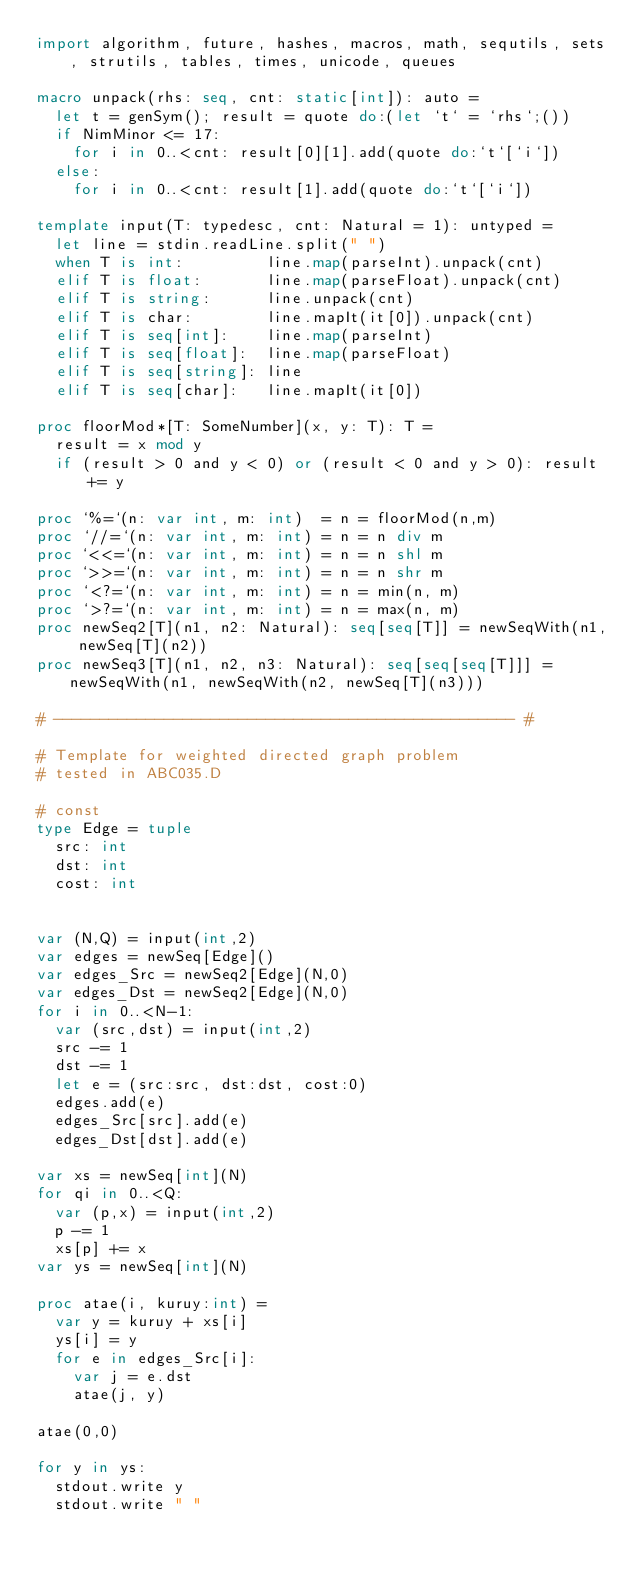Convert code to text. <code><loc_0><loc_0><loc_500><loc_500><_Nim_>import algorithm, future, hashes, macros, math, sequtils, sets, strutils, tables, times, unicode, queues
 
macro unpack(rhs: seq, cnt: static[int]): auto =
  let t = genSym(); result = quote do:(let `t` = `rhs`;())
  if NimMinor <= 17:
    for i in 0..<cnt: result[0][1].add(quote do:`t`[`i`])
  else:
    for i in 0..<cnt: result[1].add(quote do:`t`[`i`])
 
template input(T: typedesc, cnt: Natural = 1): untyped =
  let line = stdin.readLine.split(" ")
  when T is int:         line.map(parseInt).unpack(cnt)
  elif T is float:       line.map(parseFloat).unpack(cnt)
  elif T is string:      line.unpack(cnt)
  elif T is char:        line.mapIt(it[0]).unpack(cnt)
  elif T is seq[int]:    line.map(parseInt)
  elif T is seq[float]:  line.map(parseFloat)
  elif T is seq[string]: line
  elif T is seq[char]:   line.mapIt(it[0])

proc floorMod*[T: SomeNumber](x, y: T): T =
  result = x mod y
  if (result > 0 and y < 0) or (result < 0 and y > 0): result += y

proc `%=`(n: var int, m: int)  = n = floorMod(n,m)
proc `//=`(n: var int, m: int) = n = n div m
proc `<<=`(n: var int, m: int) = n = n shl m
proc `>>=`(n: var int, m: int) = n = n shr m
proc `<?=`(n: var int, m: int) = n = min(n, m)
proc `>?=`(n: var int, m: int) = n = max(n, m)
proc newSeq2[T](n1, n2: Natural): seq[seq[T]] = newSeqWith(n1, newSeq[T](n2))
proc newSeq3[T](n1, n2, n3: Natural): seq[seq[seq[T]]] = newSeqWith(n1, newSeqWith(n2, newSeq[T](n3)))
 
# -------------------------------------------------- #

# Template for weighted directed graph problem
# tested in ABC035.D

# const
type Edge = tuple
  src: int
  dst: int
  cost: int


var (N,Q) = input(int,2)
var edges = newSeq[Edge]()
var edges_Src = newSeq2[Edge](N,0)
var edges_Dst = newSeq2[Edge](N,0)
for i in 0..<N-1:
  var (src,dst) = input(int,2)
  src -= 1
  dst -= 1
  let e = (src:src, dst:dst, cost:0)
  edges.add(e)
  edges_Src[src].add(e)
  edges_Dst[dst].add(e)

var xs = newSeq[int](N)
for qi in 0..<Q:
  var (p,x) = input(int,2)
  p -= 1
  xs[p] += x
var ys = newSeq[int](N)

proc atae(i, kuruy:int) =
  var y = kuruy + xs[i]
  ys[i] = y
  for e in edges_Src[i]:
    var j = e.dst
    atae(j, y)

atae(0,0)

for y in ys:
  stdout.write y
  stdout.write " "

</code> 